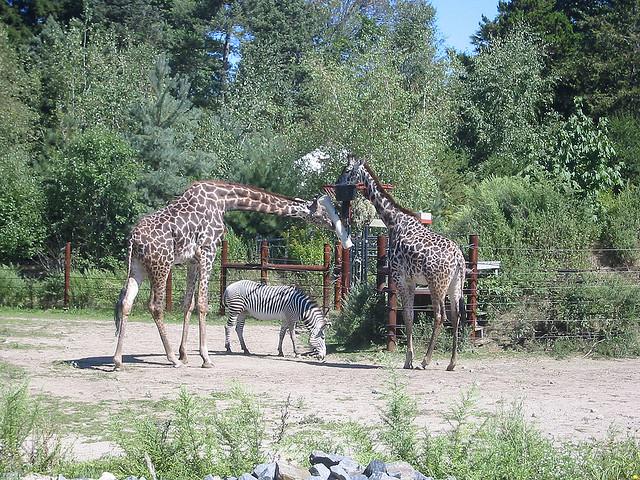What type of animal are standing around?
Be succinct. Giraffe. How many small giraffes?
Answer briefly. 0. Is there a zebra?
Quick response, please. Yes. How many animals can be seen?
Short answer required. 3. 